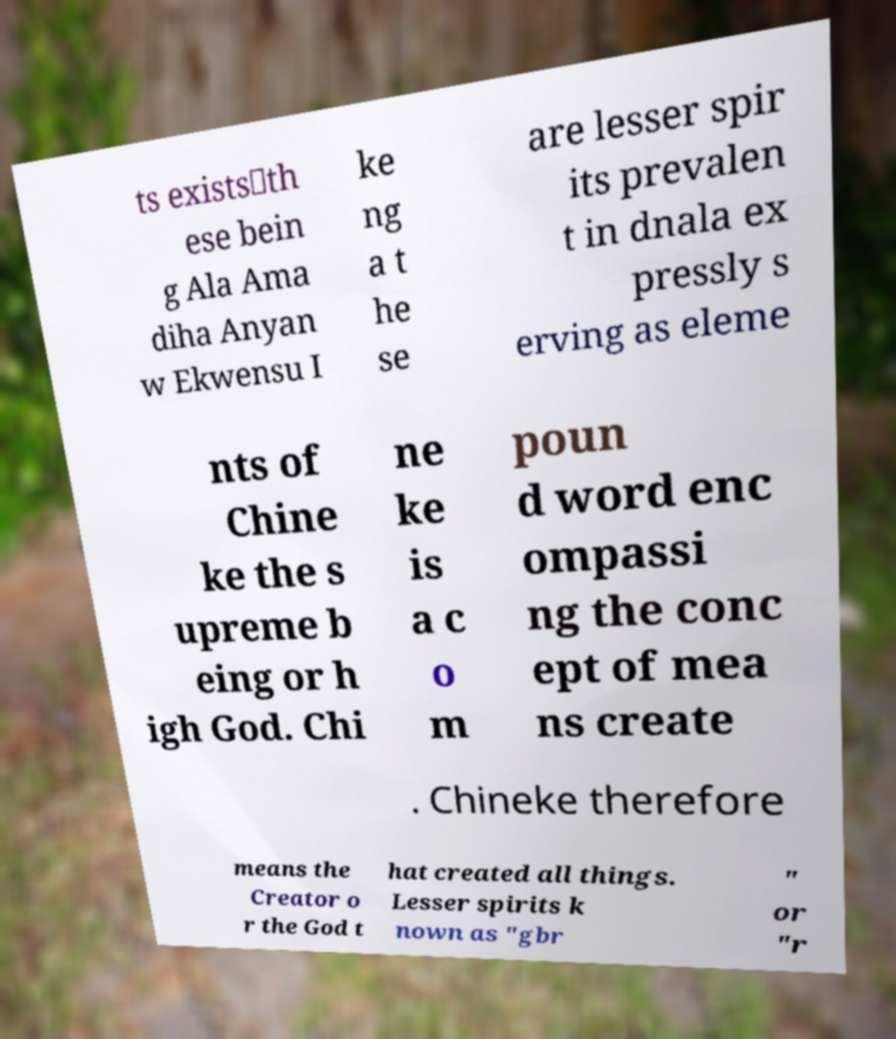Please read and relay the text visible in this image. What does it say? ts exists⸺th ese bein g Ala Ama diha Anyan w Ekwensu I ke ng a t he se are lesser spir its prevalen t in dnala ex pressly s erving as eleme nts of Chine ke the s upreme b eing or h igh God. Chi ne ke is a c o m poun d word enc ompassi ng the conc ept of mea ns create . Chineke therefore means the Creator o r the God t hat created all things. Lesser spirits k nown as "gbr " or "r 